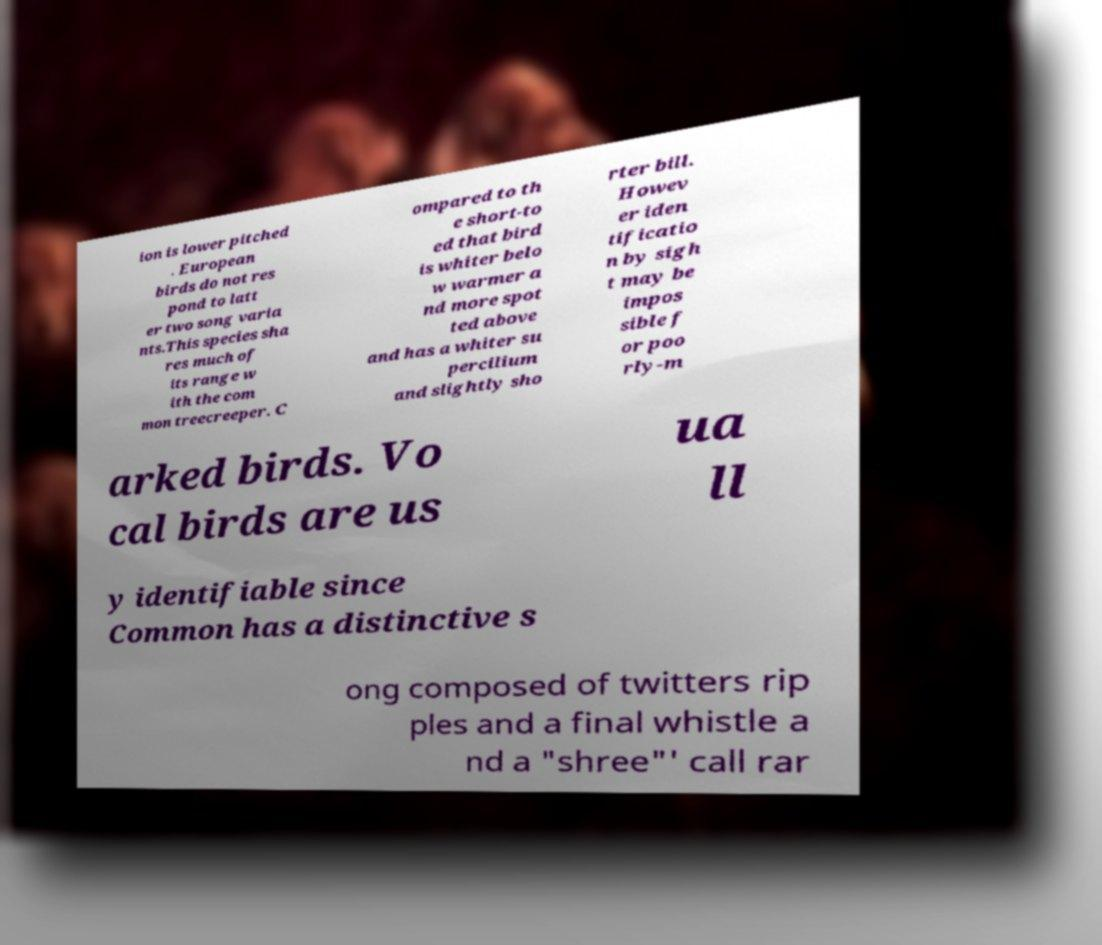For documentation purposes, I need the text within this image transcribed. Could you provide that? ion is lower pitched . European birds do not res pond to latt er two song varia nts.This species sha res much of its range w ith the com mon treecreeper. C ompared to th e short-to ed that bird is whiter belo w warmer a nd more spot ted above and has a whiter su percilium and slightly sho rter bill. Howev er iden tificatio n by sigh t may be impos sible f or poo rly-m arked birds. Vo cal birds are us ua ll y identifiable since Common has a distinctive s ong composed of twitters rip ples and a final whistle a nd a "shree"' call rar 